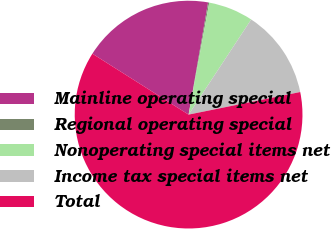Convert chart to OTSL. <chart><loc_0><loc_0><loc_500><loc_500><pie_chart><fcel>Mainline operating special<fcel>Regional operating special<fcel>Nonoperating special items net<fcel>Income tax special items net<fcel>Total<nl><fcel>18.76%<fcel>0.16%<fcel>6.36%<fcel>12.56%<fcel>62.16%<nl></chart> 